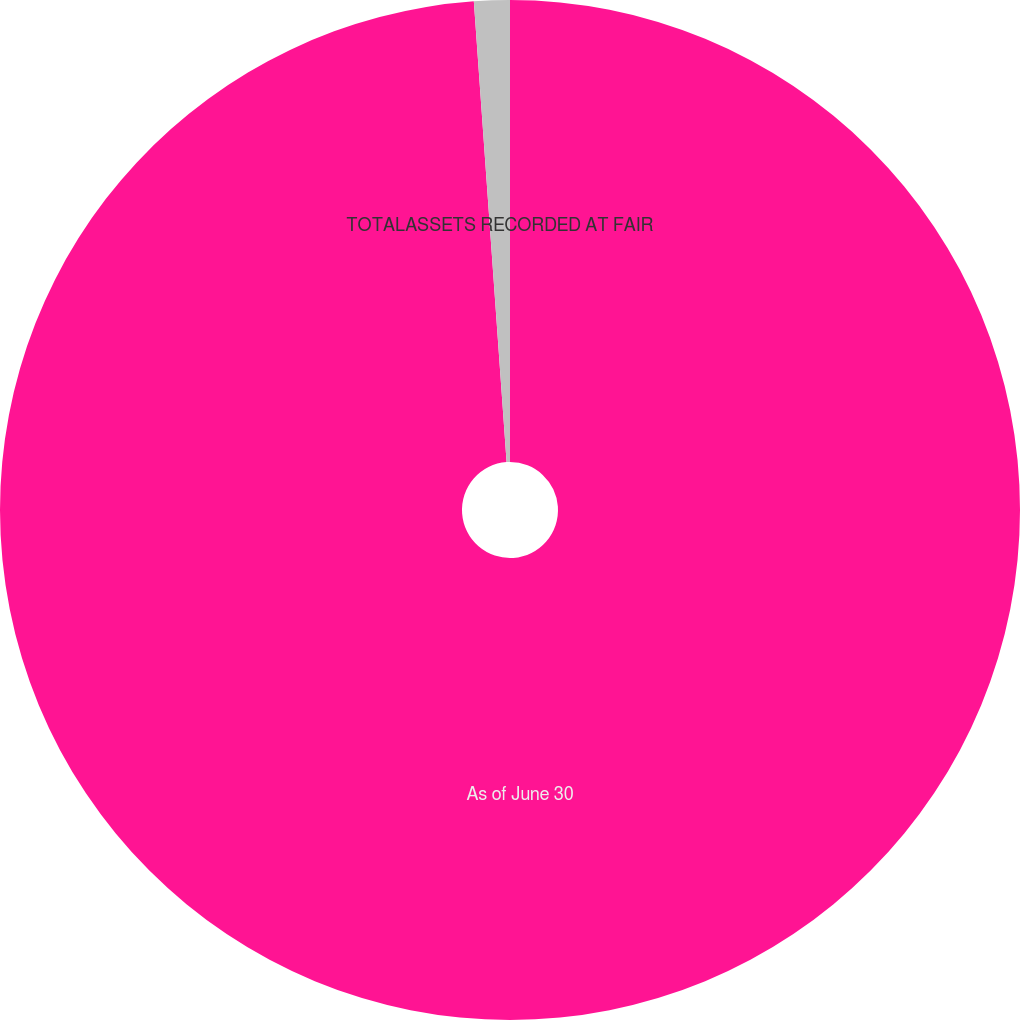Convert chart. <chart><loc_0><loc_0><loc_500><loc_500><pie_chart><fcel>As of June 30<fcel>TOTALASSETS RECORDED AT FAIR<nl><fcel>98.87%<fcel>1.13%<nl></chart> 